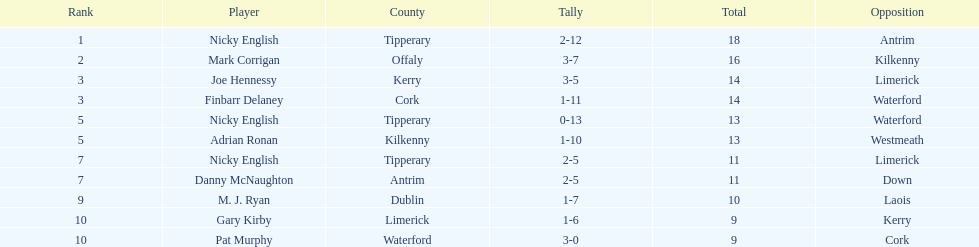How many times was waterford the opposition? 2. Write the full table. {'header': ['Rank', 'Player', 'County', 'Tally', 'Total', 'Opposition'], 'rows': [['1', 'Nicky English', 'Tipperary', '2-12', '18', 'Antrim'], ['2', 'Mark Corrigan', 'Offaly', '3-7', '16', 'Kilkenny'], ['3', 'Joe Hennessy', 'Kerry', '3-5', '14', 'Limerick'], ['3', 'Finbarr Delaney', 'Cork', '1-11', '14', 'Waterford'], ['5', 'Nicky English', 'Tipperary', '0-13', '13', 'Waterford'], ['5', 'Adrian Ronan', 'Kilkenny', '1-10', '13', 'Westmeath'], ['7', 'Nicky English', 'Tipperary', '2-5', '11', 'Limerick'], ['7', 'Danny McNaughton', 'Antrim', '2-5', '11', 'Down'], ['9', 'M. J. Ryan', 'Dublin', '1-7', '10', 'Laois'], ['10', 'Gary Kirby', 'Limerick', '1-6', '9', 'Kerry'], ['10', 'Pat Murphy', 'Waterford', '3-0', '9', 'Cork']]} 